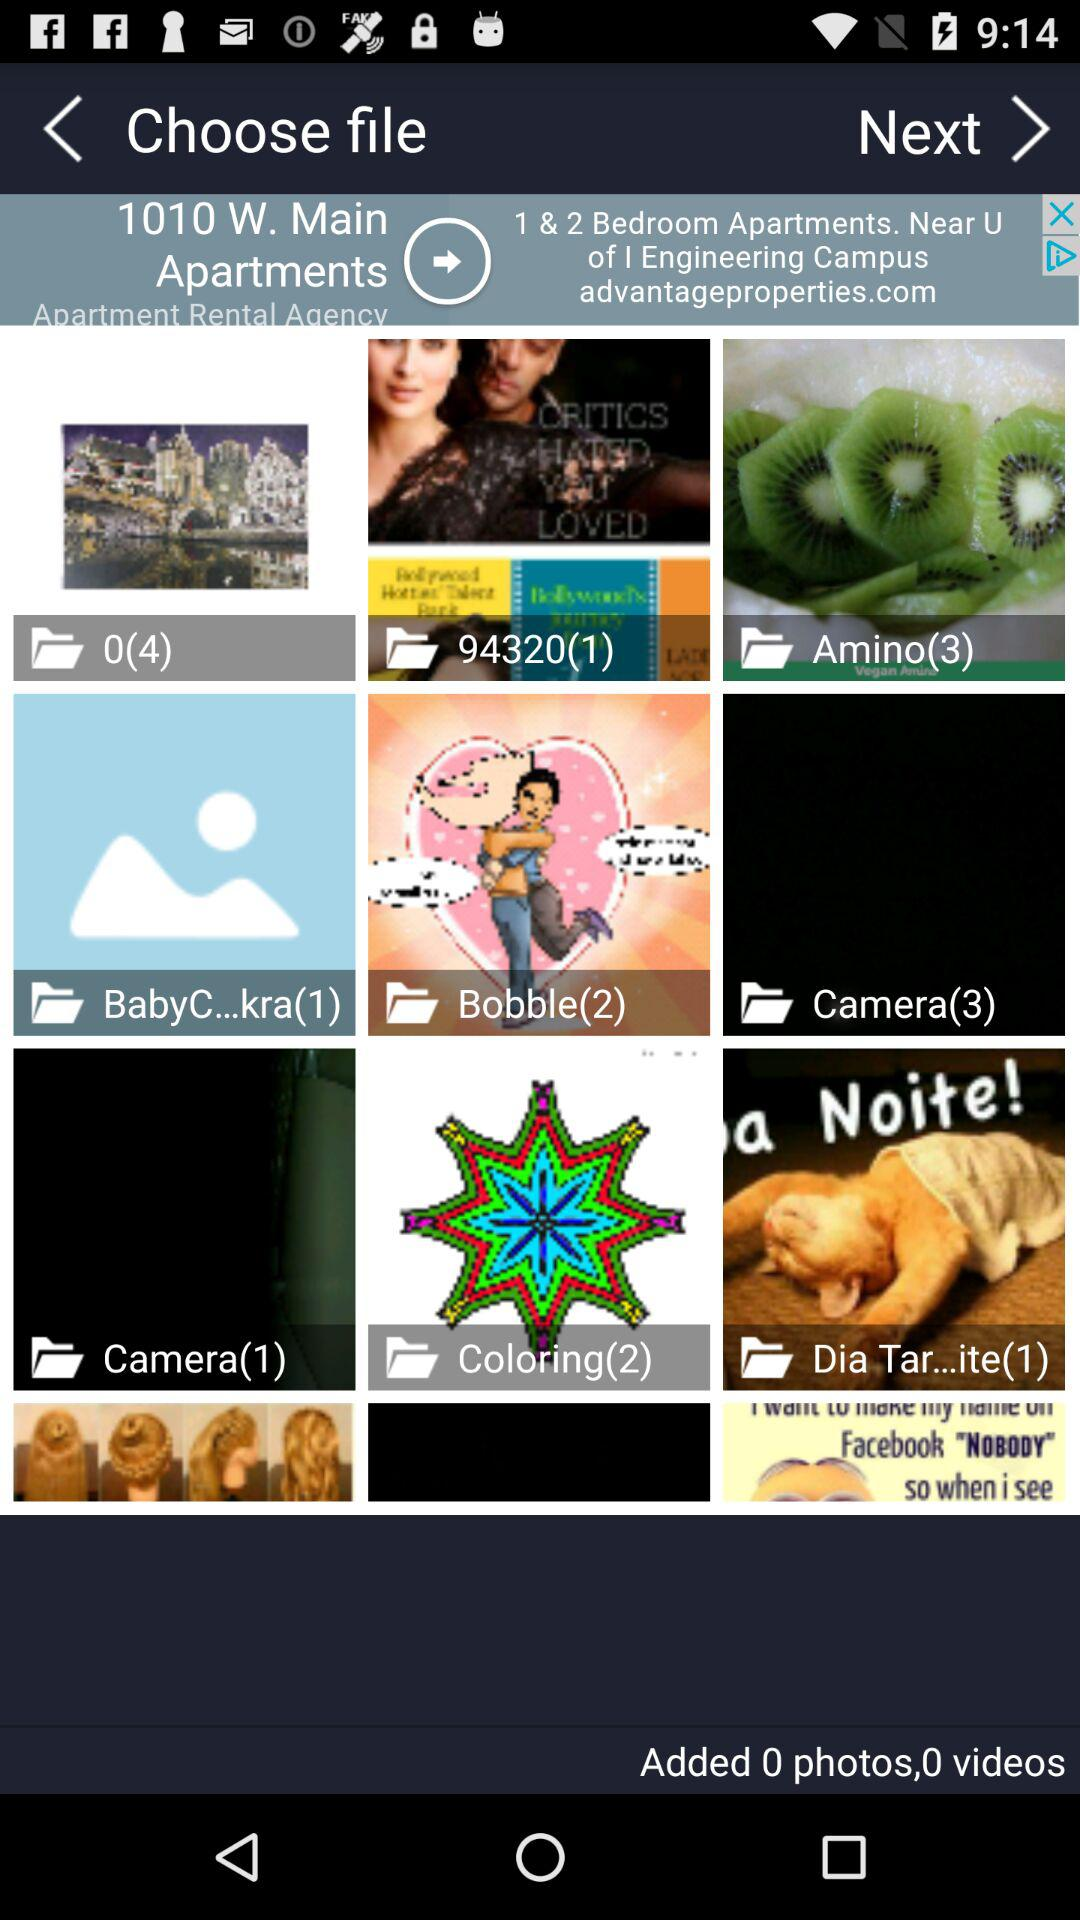How many images are in "BabyC...kra"? There is 1 image in "BabyC...kra". 